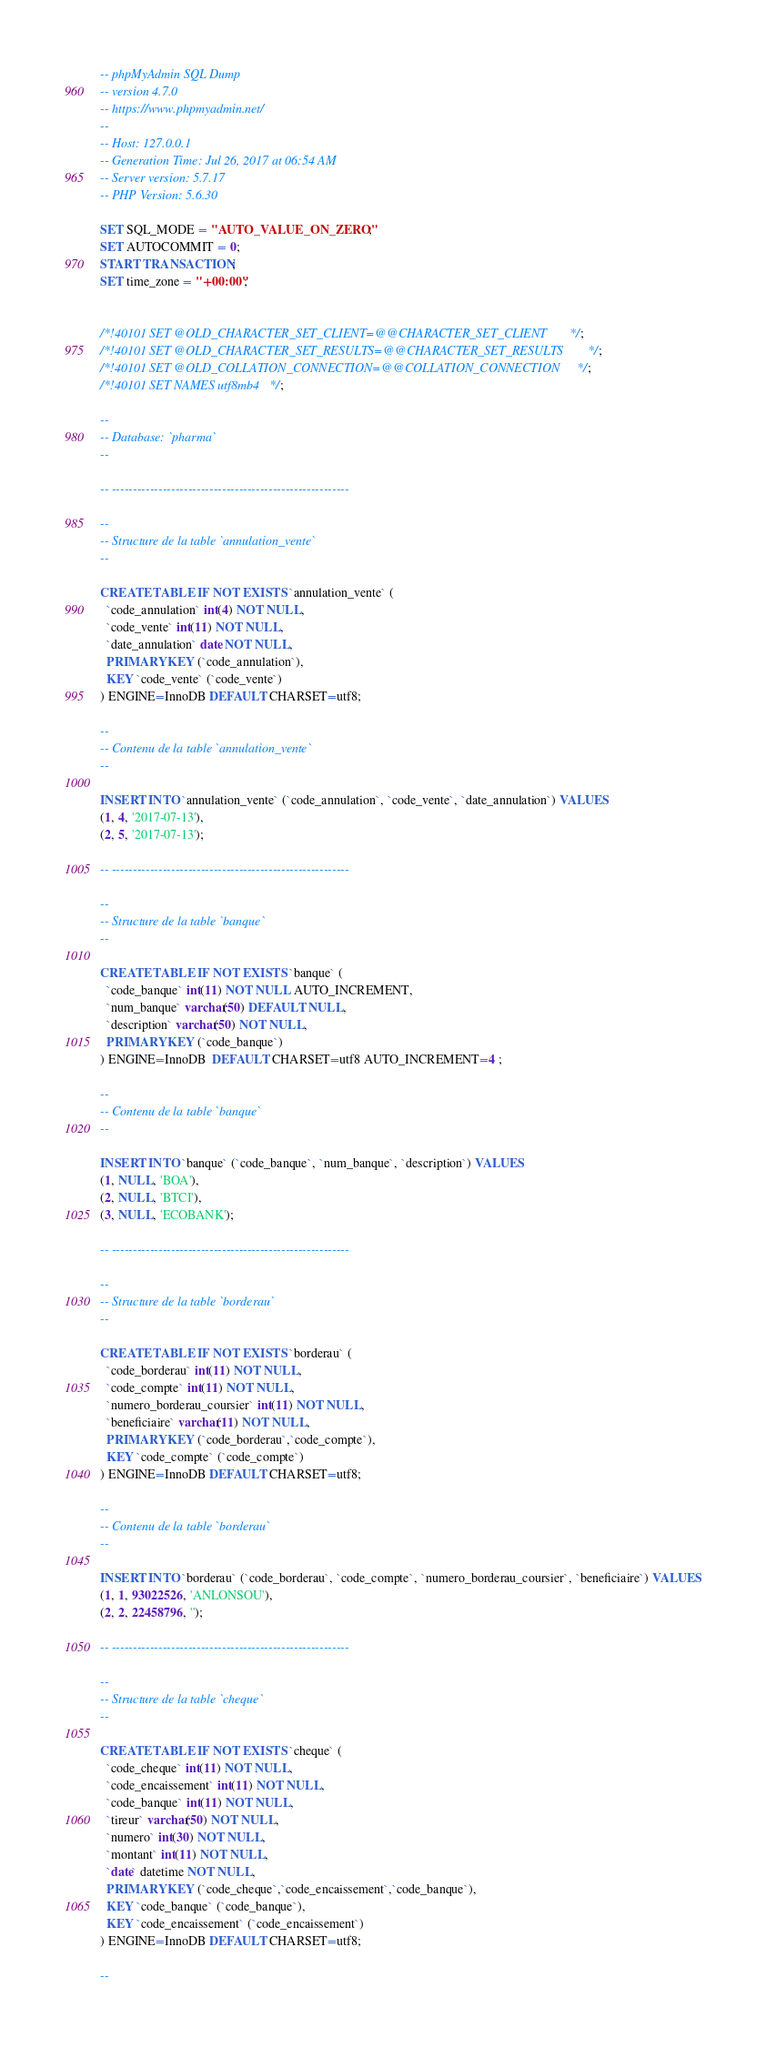<code> <loc_0><loc_0><loc_500><loc_500><_SQL_>-- phpMyAdmin SQL Dump
-- version 4.7.0
-- https://www.phpmyadmin.net/
--
-- Host: 127.0.0.1
-- Generation Time: Jul 26, 2017 at 06:54 AM
-- Server version: 5.7.17
-- PHP Version: 5.6.30

SET SQL_MODE = "AUTO_VALUE_ON_ZERO";
SET AUTOCOMMIT = 0;
START TRANSACTION;
SET time_zone = "+00:00";


/*!40101 SET @OLD_CHARACTER_SET_CLIENT=@@CHARACTER_SET_CLIENT */;
/*!40101 SET @OLD_CHARACTER_SET_RESULTS=@@CHARACTER_SET_RESULTS */;
/*!40101 SET @OLD_COLLATION_CONNECTION=@@COLLATION_CONNECTION */;
/*!40101 SET NAMES utf8mb4 */;

--
-- Database: `pharma`
--

-- --------------------------------------------------------

--
-- Structure de la table `annulation_vente`
--

CREATE TABLE IF NOT EXISTS `annulation_vente` (
  `code_annulation` int(4) NOT NULL,
  `code_vente` int(11) NOT NULL,
  `date_annulation` date NOT NULL,
  PRIMARY KEY (`code_annulation`),
  KEY `code_vente` (`code_vente`)
) ENGINE=InnoDB DEFAULT CHARSET=utf8;

--
-- Contenu de la table `annulation_vente`
--

INSERT INTO `annulation_vente` (`code_annulation`, `code_vente`, `date_annulation`) VALUES
(1, 4, '2017-07-13'),
(2, 5, '2017-07-13');

-- --------------------------------------------------------

--
-- Structure de la table `banque`
--

CREATE TABLE IF NOT EXISTS `banque` (
  `code_banque` int(11) NOT NULL AUTO_INCREMENT,
  `num_banque` varchar(50) DEFAULT NULL,
  `description` varchar(50) NOT NULL,
  PRIMARY KEY (`code_banque`)
) ENGINE=InnoDB  DEFAULT CHARSET=utf8 AUTO_INCREMENT=4 ;

--
-- Contenu de la table `banque`
--

INSERT INTO `banque` (`code_banque`, `num_banque`, `description`) VALUES
(1, NULL, 'BOA'),
(2, NULL, 'BTCI'),
(3, NULL, 'ECOBANK');

-- --------------------------------------------------------

--
-- Structure de la table `borderau`
--

CREATE TABLE IF NOT EXISTS `borderau` (
  `code_borderau` int(11) NOT NULL,
  `code_compte` int(11) NOT NULL,
  `numero_borderau_coursier` int(11) NOT NULL,
  `beneficiaire` varchar(11) NOT NULL,
  PRIMARY KEY (`code_borderau`,`code_compte`),
  KEY `code_compte` (`code_compte`)
) ENGINE=InnoDB DEFAULT CHARSET=utf8;

--
-- Contenu de la table `borderau`
--

INSERT INTO `borderau` (`code_borderau`, `code_compte`, `numero_borderau_coursier`, `beneficiaire`) VALUES
(1, 1, 93022526, 'ANLONSOU'),
(2, 2, 22458796, '');

-- --------------------------------------------------------

--
-- Structure de la table `cheque`
--

CREATE TABLE IF NOT EXISTS `cheque` (
  `code_cheque` int(11) NOT NULL,
  `code_encaissement` int(11) NOT NULL,
  `code_banque` int(11) NOT NULL,
  `tireur` varchar(50) NOT NULL,
  `numero` int(30) NOT NULL,
  `montant` int(11) NOT NULL,
  `date` datetime NOT NULL,
  PRIMARY KEY (`code_cheque`,`code_encaissement`,`code_banque`),
  KEY `code_banque` (`code_banque`),
  KEY `code_encaissement` (`code_encaissement`)
) ENGINE=InnoDB DEFAULT CHARSET=utf8;

--</code> 